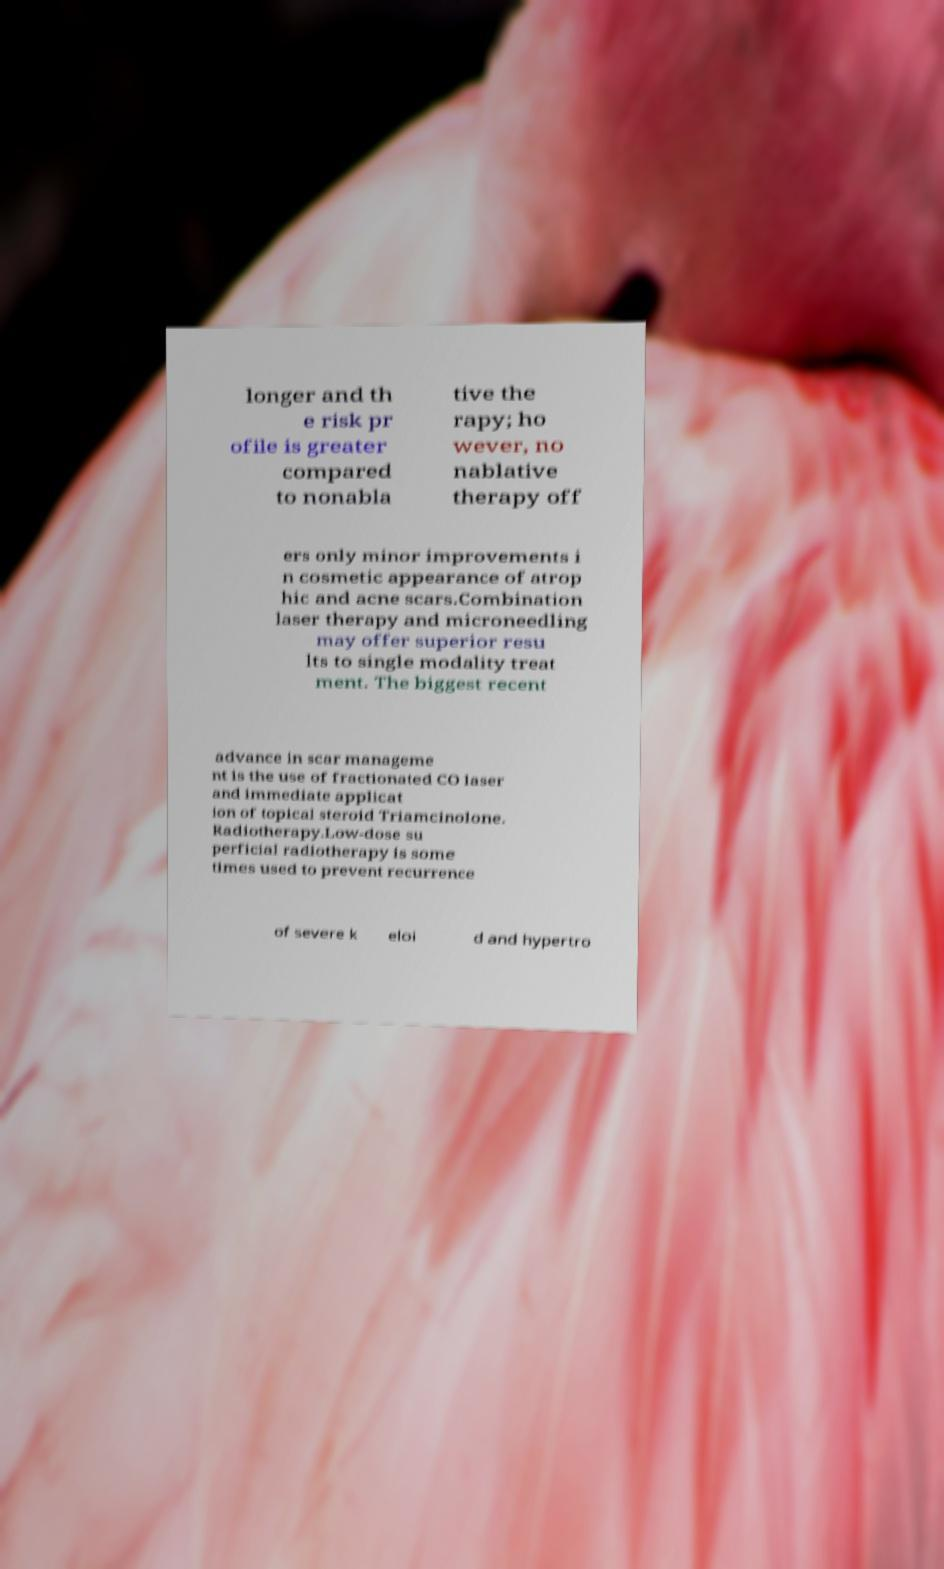Can you read and provide the text displayed in the image?This photo seems to have some interesting text. Can you extract and type it out for me? longer and th e risk pr ofile is greater compared to nonabla tive the rapy; ho wever, no nablative therapy off ers only minor improvements i n cosmetic appearance of atrop hic and acne scars.Combination laser therapy and microneedling may offer superior resu lts to single modality treat ment. The biggest recent advance in scar manageme nt is the use of fractionated CO laser and immediate applicat ion of topical steroid Triamcinolone. Radiotherapy.Low-dose su perficial radiotherapy is some times used to prevent recurrence of severe k eloi d and hypertro 